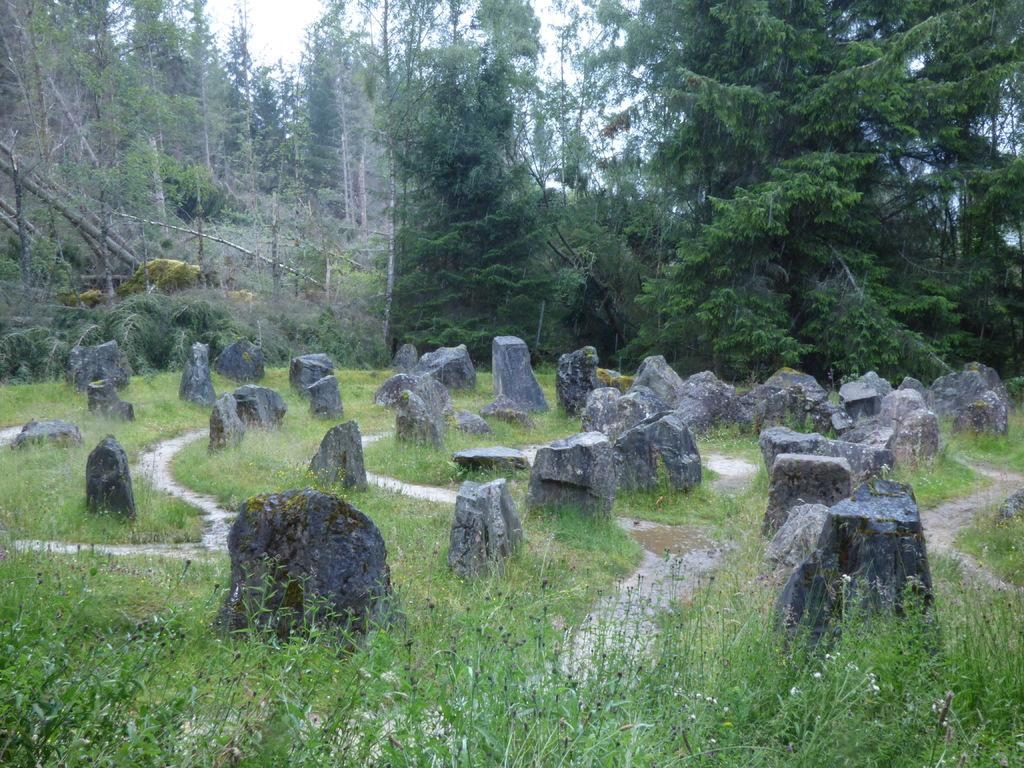What type of natural elements can be seen on the ground in the image? There are rocks on the ground in the image. What is growing between the rocks on the ground? There is grass between the rocks on the ground. What can be seen behind the rocks in the image? There are trees visible behind the rocks. What part of the trees is visible behind the rocks? Tree trunks are present behind the rocks. What is visible at the top of the image? The sky is visible at the top of the image. Can you see any veils on the trees in the image? There are no veils present on the trees in the image. What type of pets can be seen playing with the rocks in the image? There are no pets visible in the image; it features rocks, grass, trees, and the sky. 